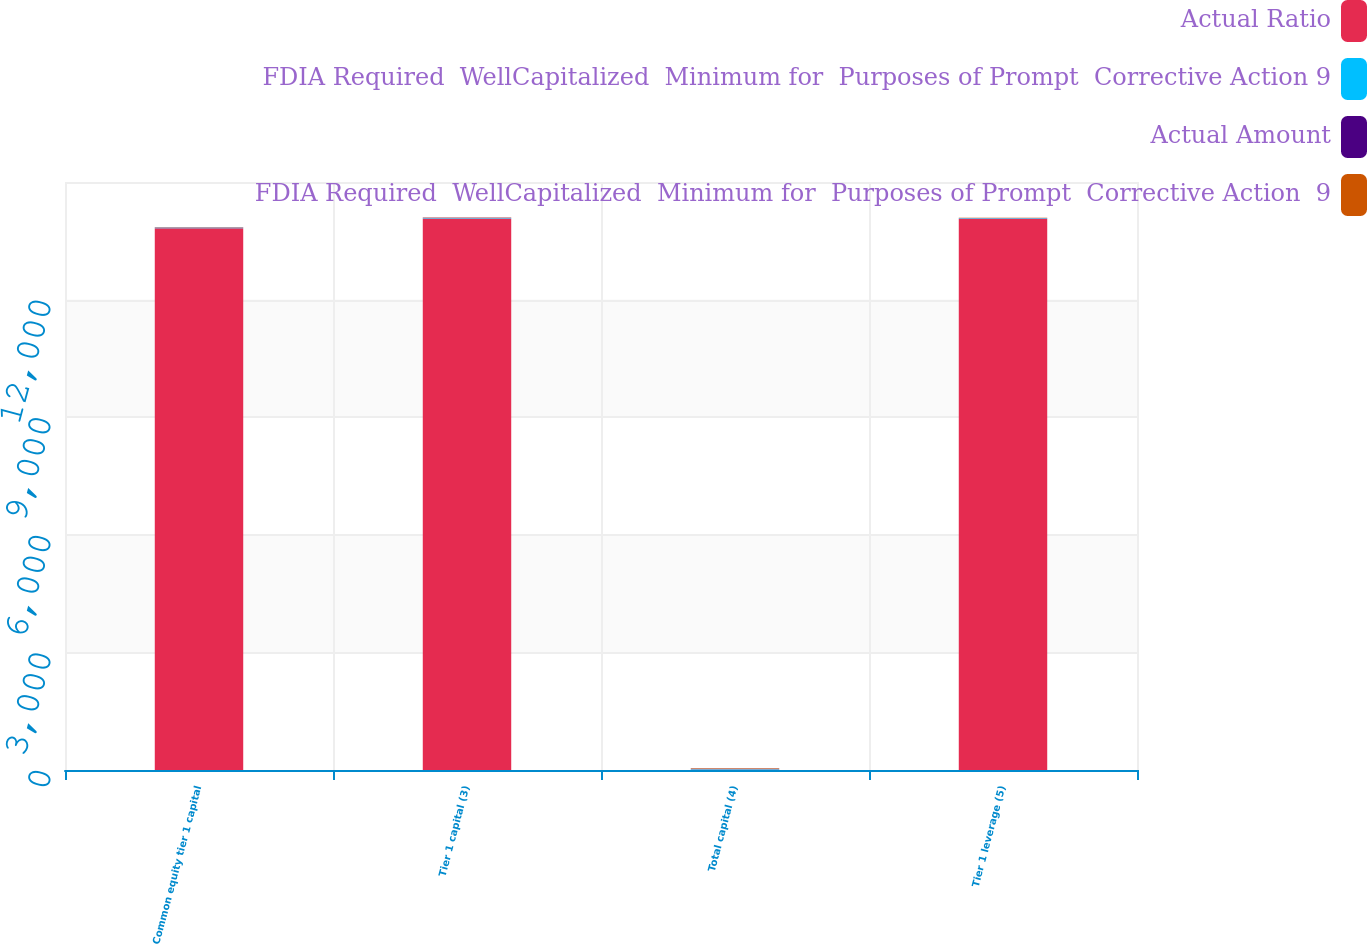Convert chart. <chart><loc_0><loc_0><loc_500><loc_500><stacked_bar_chart><ecel><fcel>Common equity tier 1 capital<fcel>Tier 1 capital (3)<fcel>Total capital (4)<fcel>Tier 1 leverage (5)<nl><fcel>Actual Ratio<fcel>13822<fcel>14069<fcel>9.9<fcel>14069<nl><fcel>FDIA Required  WellCapitalized  Minimum for  Purposes of Prompt  Corrective Action 9<fcel>11.2<fcel>11.4<fcel>14<fcel>9.9<nl><fcel>Actual Amount<fcel>5.1<fcel>6.6<fcel>8.6<fcel>4<nl><fcel>FDIA Required  WellCapitalized  Minimum for  Purposes of Prompt  Corrective Action  9<fcel>6.5<fcel>8<fcel>10<fcel>5<nl></chart> 